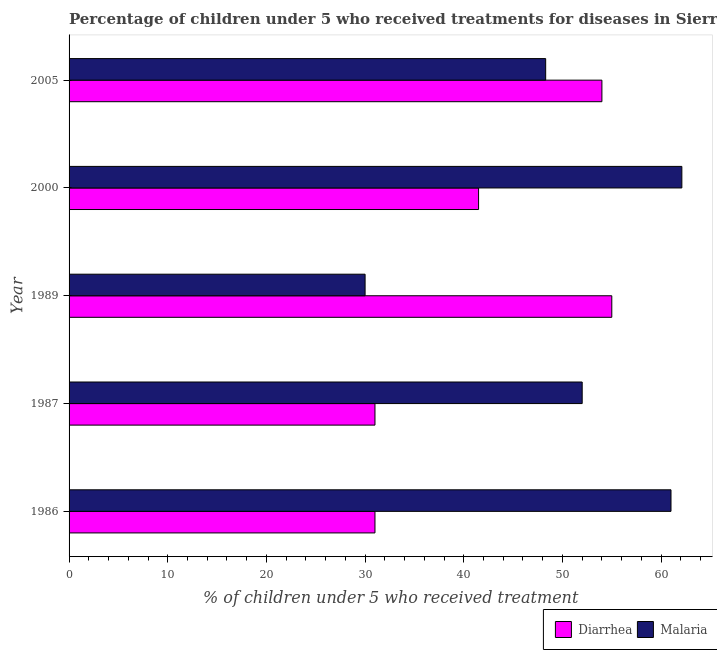What is the percentage of children who received treatment for diarrhoea in 2005?
Your response must be concise. 54. Across all years, what is the maximum percentage of children who received treatment for diarrhoea?
Your answer should be compact. 55. Across all years, what is the minimum percentage of children who received treatment for malaria?
Make the answer very short. 30. In which year was the percentage of children who received treatment for diarrhoea maximum?
Make the answer very short. 1989. In which year was the percentage of children who received treatment for malaria minimum?
Your answer should be very brief. 1989. What is the total percentage of children who received treatment for diarrhoea in the graph?
Give a very brief answer. 212.5. What is the average percentage of children who received treatment for diarrhoea per year?
Offer a very short reply. 42.5. What is the ratio of the percentage of children who received treatment for malaria in 1987 to that in 2005?
Offer a terse response. 1.08. What is the difference between the highest and the second highest percentage of children who received treatment for malaria?
Give a very brief answer. 1.1. What is the difference between the highest and the lowest percentage of children who received treatment for diarrhoea?
Provide a short and direct response. 24. What does the 1st bar from the top in 1987 represents?
Provide a short and direct response. Malaria. What does the 2nd bar from the bottom in 2000 represents?
Give a very brief answer. Malaria. Are all the bars in the graph horizontal?
Give a very brief answer. Yes. How many years are there in the graph?
Make the answer very short. 5. What is the difference between two consecutive major ticks on the X-axis?
Give a very brief answer. 10. Are the values on the major ticks of X-axis written in scientific E-notation?
Ensure brevity in your answer.  No. Does the graph contain grids?
Provide a short and direct response. No. Where does the legend appear in the graph?
Offer a terse response. Bottom right. How many legend labels are there?
Your answer should be very brief. 2. What is the title of the graph?
Offer a terse response. Percentage of children under 5 who received treatments for diseases in Sierra Leone. What is the label or title of the X-axis?
Offer a terse response. % of children under 5 who received treatment. What is the label or title of the Y-axis?
Offer a very short reply. Year. What is the % of children under 5 who received treatment in Diarrhea in 1986?
Provide a short and direct response. 31. What is the % of children under 5 who received treatment in Malaria in 1987?
Offer a terse response. 52. What is the % of children under 5 who received treatment in Diarrhea in 2000?
Ensure brevity in your answer.  41.5. What is the % of children under 5 who received treatment of Malaria in 2000?
Ensure brevity in your answer.  62.1. What is the % of children under 5 who received treatment of Diarrhea in 2005?
Your answer should be compact. 54. What is the % of children under 5 who received treatment of Malaria in 2005?
Your answer should be compact. 48.3. Across all years, what is the maximum % of children under 5 who received treatment in Malaria?
Offer a terse response. 62.1. Across all years, what is the minimum % of children under 5 who received treatment in Diarrhea?
Your response must be concise. 31. What is the total % of children under 5 who received treatment in Diarrhea in the graph?
Your response must be concise. 212.5. What is the total % of children under 5 who received treatment in Malaria in the graph?
Ensure brevity in your answer.  253.4. What is the difference between the % of children under 5 who received treatment of Diarrhea in 1986 and that in 1987?
Offer a very short reply. 0. What is the difference between the % of children under 5 who received treatment of Diarrhea in 1986 and that in 2000?
Your answer should be compact. -10.5. What is the difference between the % of children under 5 who received treatment in Malaria in 1986 and that in 2000?
Your response must be concise. -1.1. What is the difference between the % of children under 5 who received treatment of Diarrhea in 1986 and that in 2005?
Make the answer very short. -23. What is the difference between the % of children under 5 who received treatment in Malaria in 1986 and that in 2005?
Make the answer very short. 12.7. What is the difference between the % of children under 5 who received treatment of Diarrhea in 1987 and that in 1989?
Ensure brevity in your answer.  -24. What is the difference between the % of children under 5 who received treatment of Malaria in 1987 and that in 1989?
Your answer should be very brief. 22. What is the difference between the % of children under 5 who received treatment in Malaria in 1987 and that in 2000?
Provide a short and direct response. -10.1. What is the difference between the % of children under 5 who received treatment in Diarrhea in 1987 and that in 2005?
Offer a terse response. -23. What is the difference between the % of children under 5 who received treatment in Malaria in 1987 and that in 2005?
Give a very brief answer. 3.7. What is the difference between the % of children under 5 who received treatment of Diarrhea in 1989 and that in 2000?
Your answer should be compact. 13.5. What is the difference between the % of children under 5 who received treatment of Malaria in 1989 and that in 2000?
Your answer should be very brief. -32.1. What is the difference between the % of children under 5 who received treatment in Malaria in 1989 and that in 2005?
Your response must be concise. -18.3. What is the difference between the % of children under 5 who received treatment of Diarrhea in 2000 and that in 2005?
Your answer should be very brief. -12.5. What is the difference between the % of children under 5 who received treatment in Diarrhea in 1986 and the % of children under 5 who received treatment in Malaria in 1989?
Make the answer very short. 1. What is the difference between the % of children under 5 who received treatment in Diarrhea in 1986 and the % of children under 5 who received treatment in Malaria in 2000?
Your answer should be very brief. -31.1. What is the difference between the % of children under 5 who received treatment of Diarrhea in 1986 and the % of children under 5 who received treatment of Malaria in 2005?
Offer a terse response. -17.3. What is the difference between the % of children under 5 who received treatment in Diarrhea in 1987 and the % of children under 5 who received treatment in Malaria in 1989?
Offer a very short reply. 1. What is the difference between the % of children under 5 who received treatment in Diarrhea in 1987 and the % of children under 5 who received treatment in Malaria in 2000?
Provide a succinct answer. -31.1. What is the difference between the % of children under 5 who received treatment in Diarrhea in 1987 and the % of children under 5 who received treatment in Malaria in 2005?
Keep it short and to the point. -17.3. What is the difference between the % of children under 5 who received treatment in Diarrhea in 1989 and the % of children under 5 who received treatment in Malaria in 2000?
Your response must be concise. -7.1. What is the average % of children under 5 who received treatment in Diarrhea per year?
Your response must be concise. 42.5. What is the average % of children under 5 who received treatment in Malaria per year?
Provide a short and direct response. 50.68. In the year 1986, what is the difference between the % of children under 5 who received treatment of Diarrhea and % of children under 5 who received treatment of Malaria?
Your answer should be very brief. -30. In the year 1987, what is the difference between the % of children under 5 who received treatment of Diarrhea and % of children under 5 who received treatment of Malaria?
Offer a very short reply. -21. In the year 2000, what is the difference between the % of children under 5 who received treatment in Diarrhea and % of children under 5 who received treatment in Malaria?
Make the answer very short. -20.6. In the year 2005, what is the difference between the % of children under 5 who received treatment of Diarrhea and % of children under 5 who received treatment of Malaria?
Provide a short and direct response. 5.7. What is the ratio of the % of children under 5 who received treatment of Diarrhea in 1986 to that in 1987?
Your answer should be very brief. 1. What is the ratio of the % of children under 5 who received treatment in Malaria in 1986 to that in 1987?
Offer a terse response. 1.17. What is the ratio of the % of children under 5 who received treatment in Diarrhea in 1986 to that in 1989?
Provide a succinct answer. 0.56. What is the ratio of the % of children under 5 who received treatment of Malaria in 1986 to that in 1989?
Make the answer very short. 2.03. What is the ratio of the % of children under 5 who received treatment in Diarrhea in 1986 to that in 2000?
Make the answer very short. 0.75. What is the ratio of the % of children under 5 who received treatment of Malaria in 1986 to that in 2000?
Your response must be concise. 0.98. What is the ratio of the % of children under 5 who received treatment in Diarrhea in 1986 to that in 2005?
Give a very brief answer. 0.57. What is the ratio of the % of children under 5 who received treatment in Malaria in 1986 to that in 2005?
Offer a terse response. 1.26. What is the ratio of the % of children under 5 who received treatment in Diarrhea in 1987 to that in 1989?
Provide a succinct answer. 0.56. What is the ratio of the % of children under 5 who received treatment of Malaria in 1987 to that in 1989?
Keep it short and to the point. 1.73. What is the ratio of the % of children under 5 who received treatment in Diarrhea in 1987 to that in 2000?
Offer a very short reply. 0.75. What is the ratio of the % of children under 5 who received treatment in Malaria in 1987 to that in 2000?
Offer a terse response. 0.84. What is the ratio of the % of children under 5 who received treatment in Diarrhea in 1987 to that in 2005?
Keep it short and to the point. 0.57. What is the ratio of the % of children under 5 who received treatment in Malaria in 1987 to that in 2005?
Make the answer very short. 1.08. What is the ratio of the % of children under 5 who received treatment in Diarrhea in 1989 to that in 2000?
Offer a very short reply. 1.33. What is the ratio of the % of children under 5 who received treatment of Malaria in 1989 to that in 2000?
Provide a succinct answer. 0.48. What is the ratio of the % of children under 5 who received treatment of Diarrhea in 1989 to that in 2005?
Offer a terse response. 1.02. What is the ratio of the % of children under 5 who received treatment of Malaria in 1989 to that in 2005?
Offer a terse response. 0.62. What is the ratio of the % of children under 5 who received treatment of Diarrhea in 2000 to that in 2005?
Keep it short and to the point. 0.77. What is the ratio of the % of children under 5 who received treatment in Malaria in 2000 to that in 2005?
Keep it short and to the point. 1.29. What is the difference between the highest and the second highest % of children under 5 who received treatment of Diarrhea?
Your answer should be very brief. 1. What is the difference between the highest and the lowest % of children under 5 who received treatment in Malaria?
Keep it short and to the point. 32.1. 